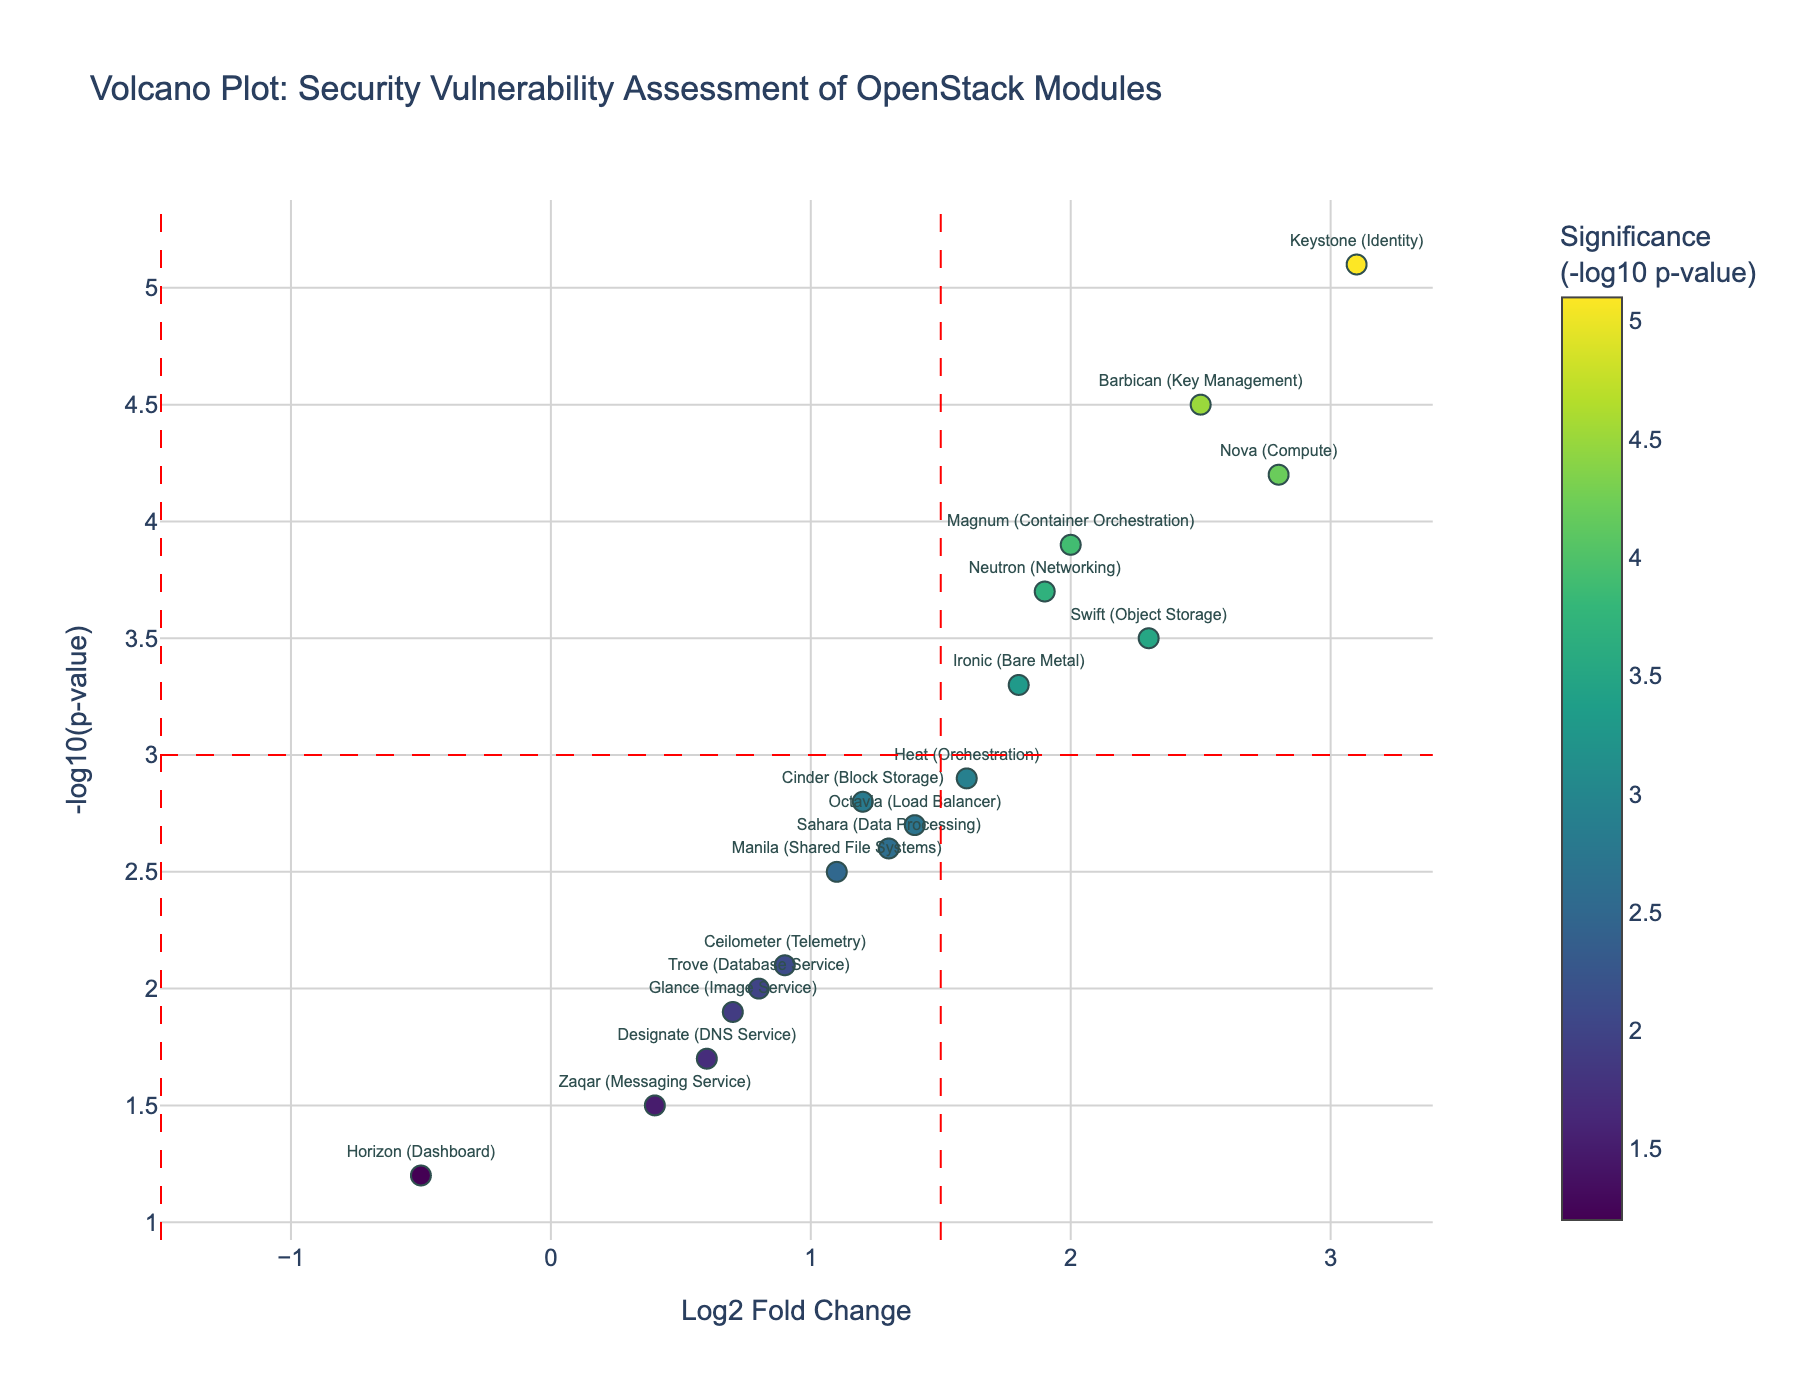What's the title of the plot? The title of the plot is typically displayed at the top of the figure. In this case, it is "Volcano Plot: Security Vulnerability Assessment of OpenStack Modules".
Answer: Volcano Plot: Security Vulnerability Assessment of OpenStack Modules How many modules have negative Log2 Fold Change values? To determine this, check the data points that are positioned on the left side of the vertical line at Log2 Fold Change = 0. Here, only the "Horizon (Dashboard)" module has a negative Log2 Fold Change value.
Answer: 1 Which module shows the highest level of statistical significance for its vulnerabilities? To find the module with the highest statistical significance, look for the highest y-axis value (Negative Log10 PValue). The "Keystone (Identity)" module has the highest value of 5.1.
Answer: Keystone (Identity) Which modules have Log2 Fold Change values greater than the threshold of 1.5? Identify the data points to the right of the vertical line at Log2 Fold Change = 1.5: Nova (Compute), Neutron (Networking), Keystone (Identity), Swift (Object Storage), Barbican (Key Management), and Magnum (Container Orchestration).
Answer: Nova, Neutron, Keystone, Swift, Barbican, Magnum What is the Log2 Fold Change and -log10(p-value) for the "Glance (Image Service)" module? Refer to the hover text or the coordinates of the point labeled "Glance (Image Service)" to find Log2FC and -log10(p-value). It has a Log2 Fold Change of 0.7 and a -log10(p-value) of 1.9.
Answer: 0.7, 1.9 How many modules exceed the -log10(p-value) threshold of 3? Check the data points above the horizontal line at -log10(p-value) = 3. The modules are: Nova (Compute), Neutron (Networking), Keystone (Identity), Swift (Object Storage), Barbican (Key Management), and Magnum (Container Orchestration).
Answer: 6 Which module has both Log2 Fold Change > 1.5 and -log10(p-value) > 3 and is closest to the center of the plot? Identify the modules that exceed both thresholds (Log2FC > 1.5 and -log10(p-value) > 3). Then, find the one closest to the origin (0,0). The "Neutron (Networking)" module fits this criterion.
Answer: Neutron Are there any modules with Log2 Fold Change greater than 2.5 and -log10(p-value) below 4? To answer this, compare the modules with Log2FC > 2.5 and check their -log10(p-value). "Barbican (Key Management)" fits this description with values of Log2FC = 2.5 and -log10(p-value) = 4.5.
Answer: No Which module has the lowest statistical significance among those with Log2 Fold Change greater than 2? Among the modules with Log2 Fold Change values greater than 2: Nova (2.8), Keystone (3.1), Swift (2.3), and Magnum (2.0), the "Magnum (Container Orchestration)" module has the lowest -log10(p-value) of 3.9.
Answer: Magnum 